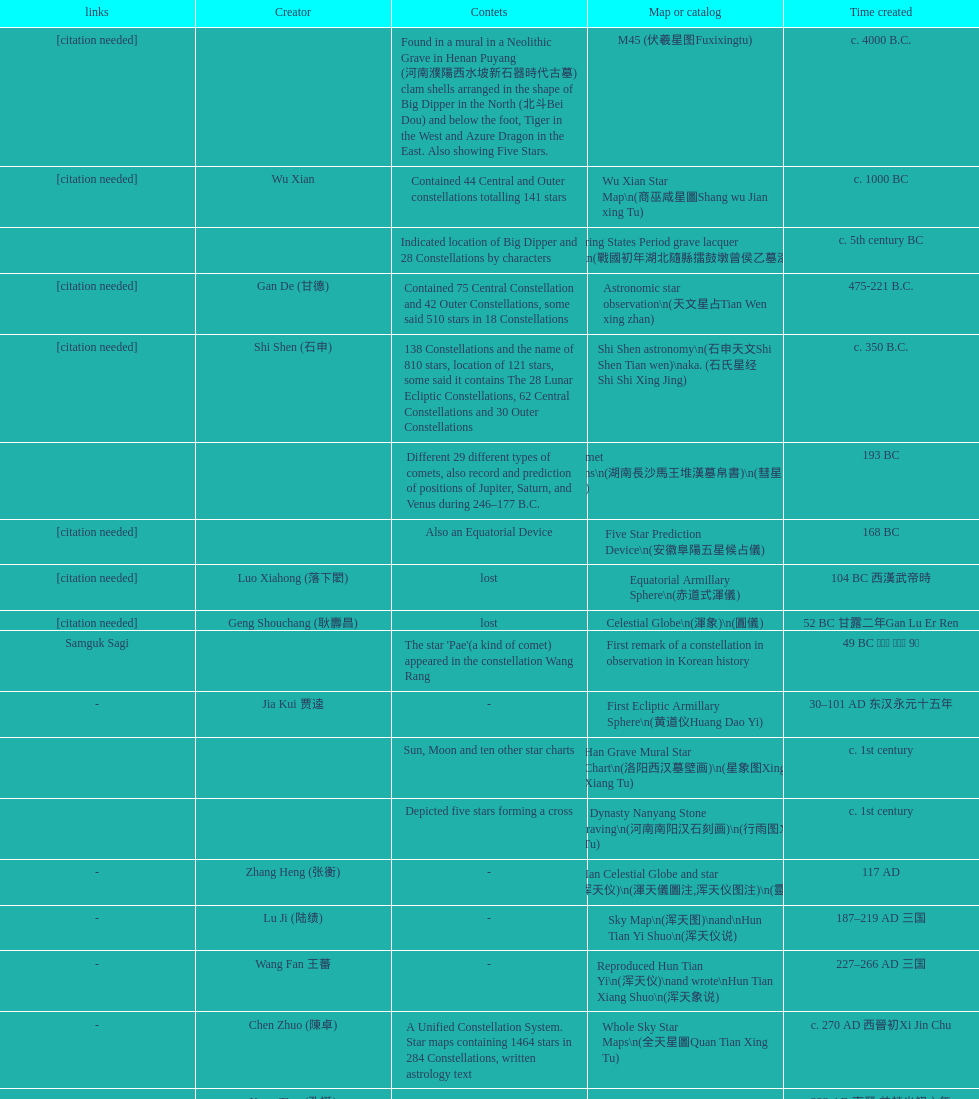Did xu guang ci or su song create the five star charts in 1094 ad? Su Song 蘇頌. 